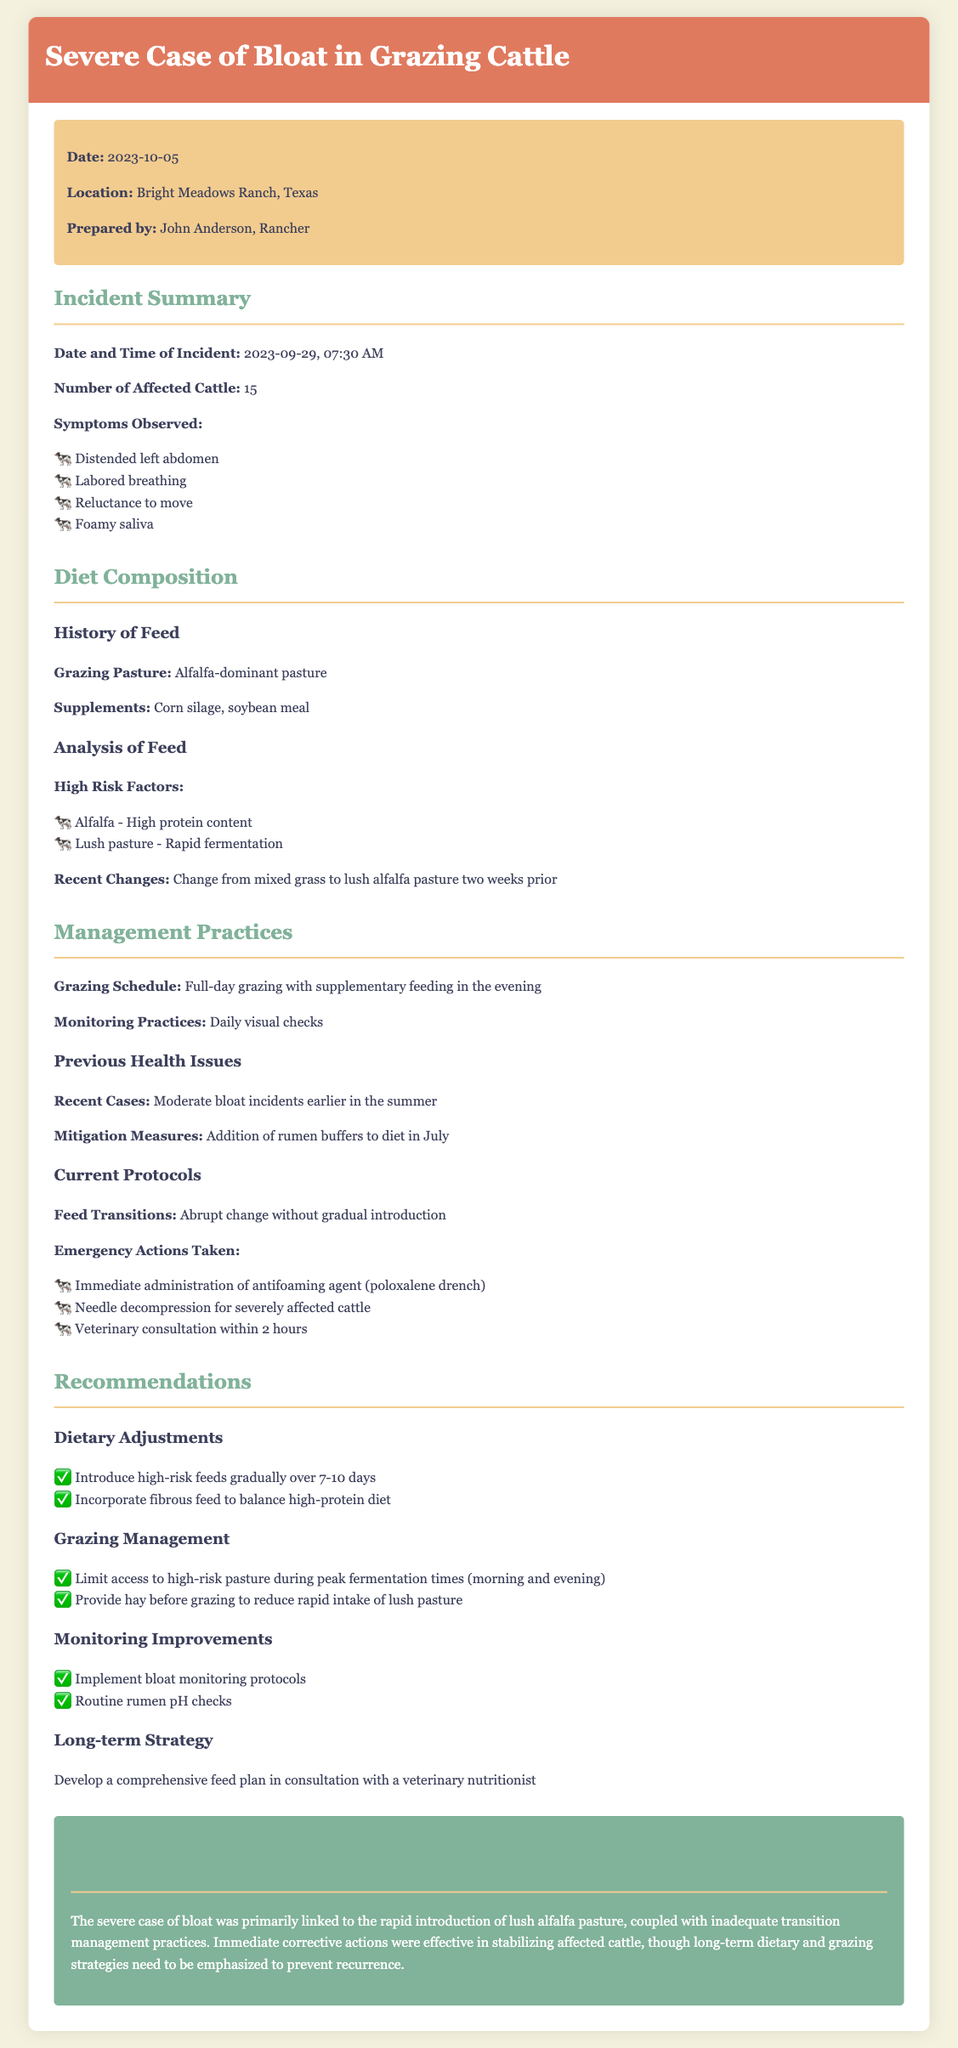what date did the incident occur? The date of the incident is stated as 2023-09-29.
Answer: 2023-09-29 how many cattle were affected? The document mentions that 15 cattle were affected.
Answer: 15 what symptoms were observed in the cattle? The symptoms listed include distended left abdomen, labored breathing, reluctance to move, and foamy saliva.
Answer: Distended left abdomen, labored breathing, reluctance to move, foamy saliva what was the grazing pasture composition? The report specifies the grazing pasture as alfalfa-dominant.
Answer: Alfalfa-dominant what immediate action was taken for the affected cattle? The document lists immediate actions such as administration of antifoaming agent and needle decompression.
Answer: Administration of antifoaming agent, needle decompression what is a recommended dietary adjustment? One key recommendation is to introduce high-risk feeds gradually over 7-10 days.
Answer: Gradually over 7-10 days what management practice should be limited during peak fermentation times? The document recommends limiting access to high-risk pasture during peak fermentation times.
Answer: Access to high-risk pasture what emergency action was taken post-incident? Emergency actions included veterinary consultation within 2 hours.
Answer: Veterinary consultation within 2 hours what was a significant contributing factor to the bloat case? The report identifies rapid introduction of lush alfalfa pasture as a significant factor.
Answer: Rapid introduction of lush alfalfa pasture 